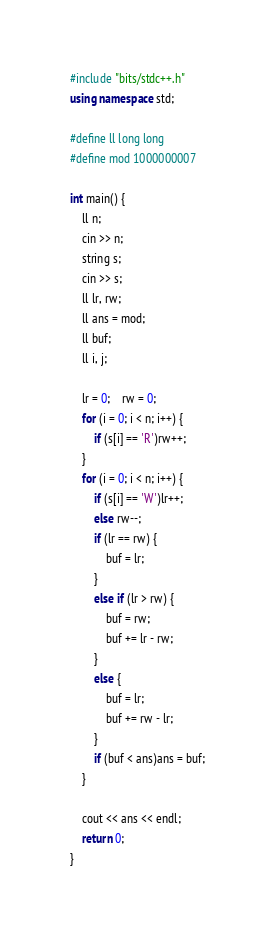<code> <loc_0><loc_0><loc_500><loc_500><_C++_>#include "bits/stdc++.h"
using namespace std;

#define ll long long
#define mod 1000000007

int main() {
	ll n;
	cin >> n;
	string s;
	cin >> s;
	ll lr, rw;
	ll ans = mod;
	ll buf;
	ll i, j;

	lr = 0;	rw = 0;
	for (i = 0; i < n; i++) {
		if (s[i] == 'R')rw++;
	}
	for (i = 0; i < n; i++) {
		if (s[i] == 'W')lr++;
		else rw--;
		if (lr == rw) {
			buf = lr;
		}
		else if (lr > rw) {
			buf = rw;
			buf += lr - rw;
		}
		else {
			buf = lr;
			buf += rw - lr;
		}
		if (buf < ans)ans = buf;
	}

	cout << ans << endl;
	return 0;
}
</code> 